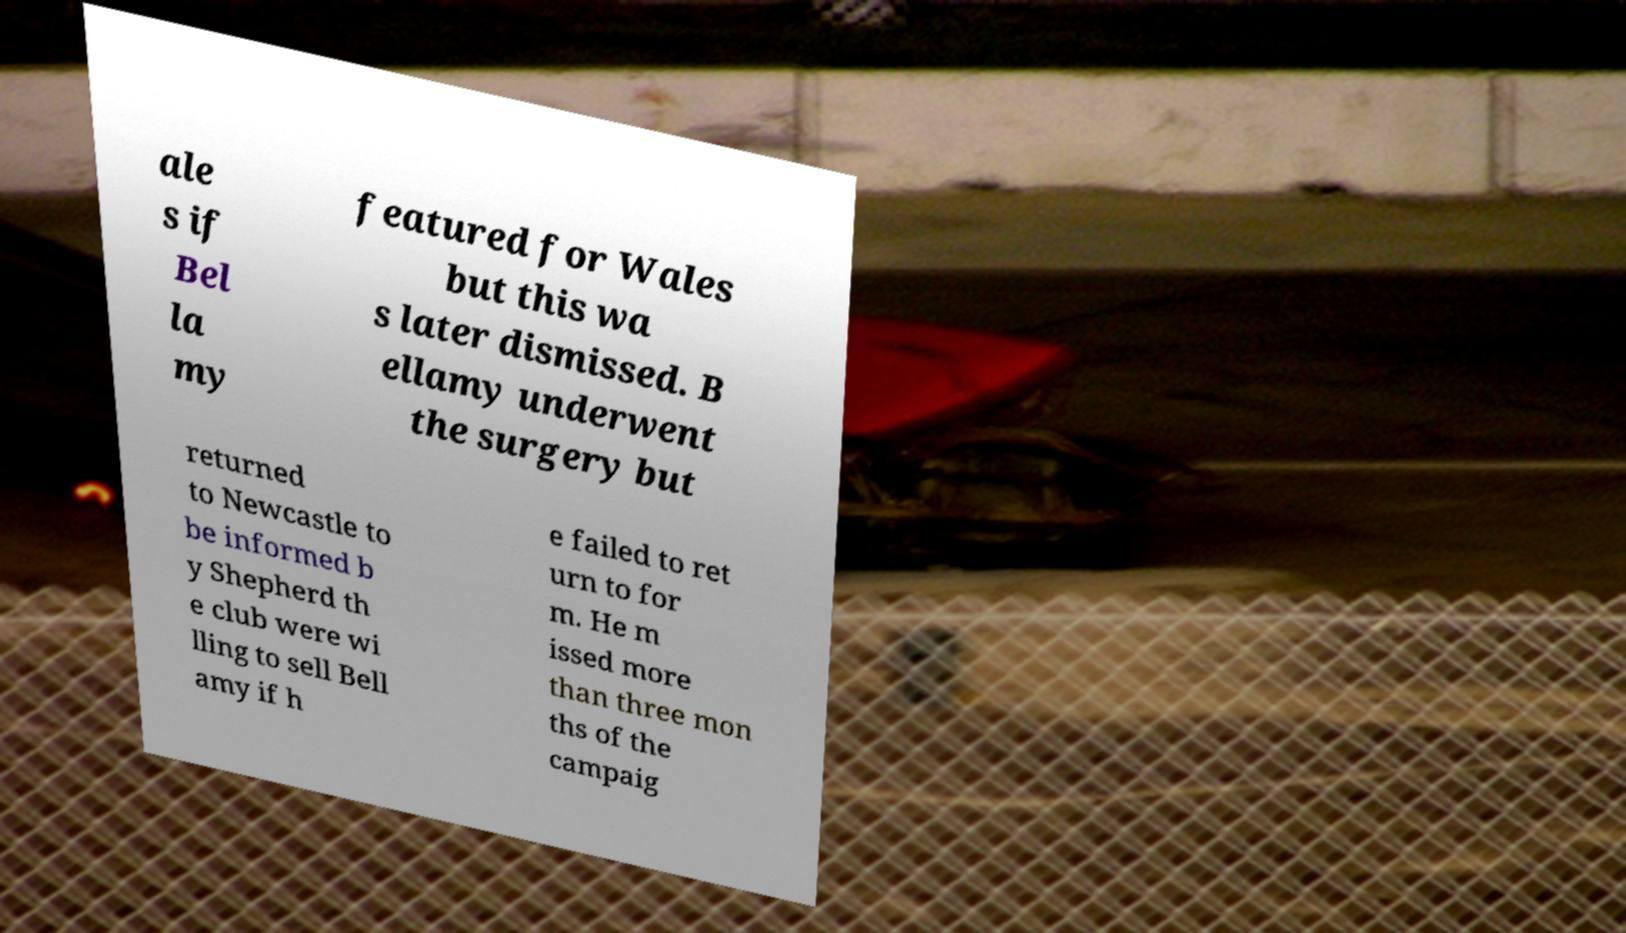For documentation purposes, I need the text within this image transcribed. Could you provide that? ale s if Bel la my featured for Wales but this wa s later dismissed. B ellamy underwent the surgery but returned to Newcastle to be informed b y Shepherd th e club were wi lling to sell Bell amy if h e failed to ret urn to for m. He m issed more than three mon ths of the campaig 